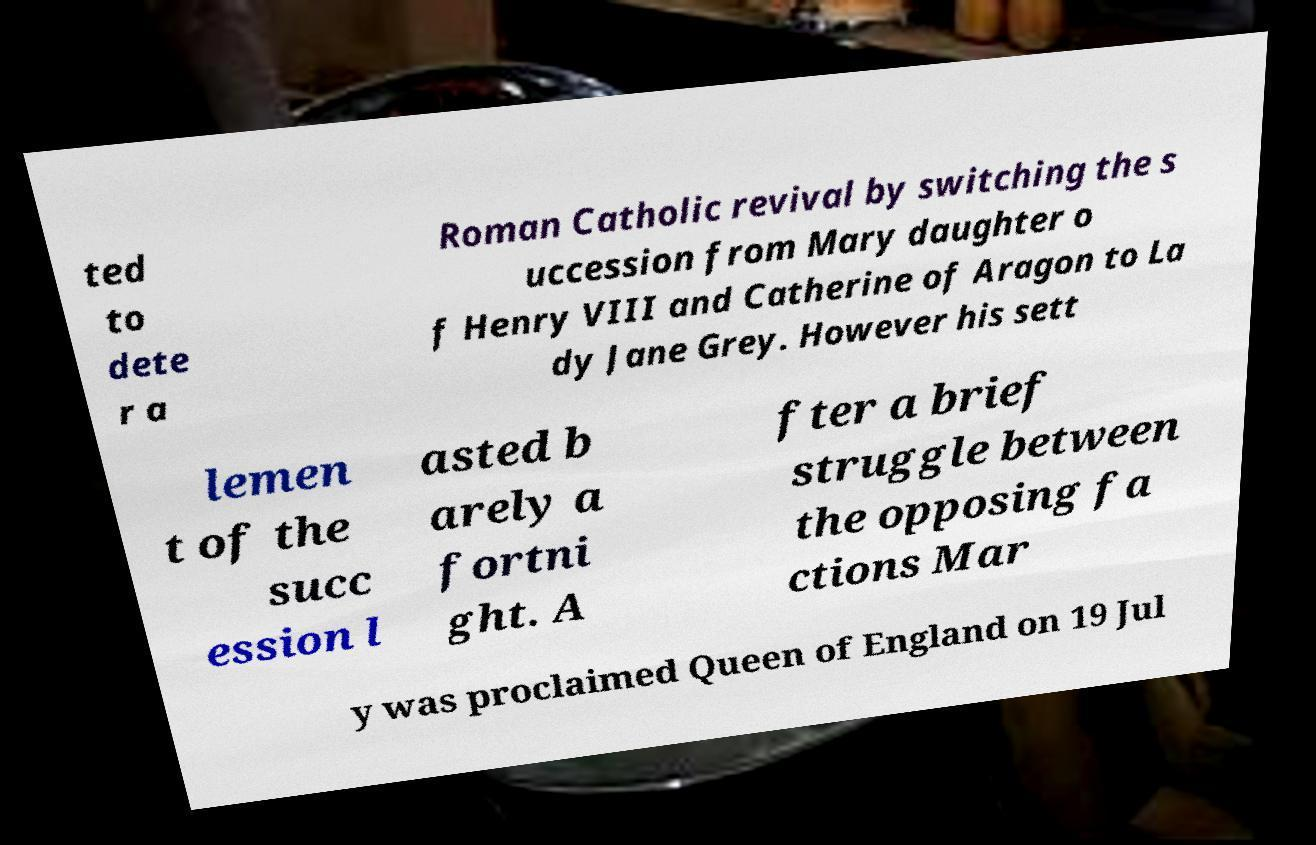There's text embedded in this image that I need extracted. Can you transcribe it verbatim? ted to dete r a Roman Catholic revival by switching the s uccession from Mary daughter o f Henry VIII and Catherine of Aragon to La dy Jane Grey. However his sett lemen t of the succ ession l asted b arely a fortni ght. A fter a brief struggle between the opposing fa ctions Mar y was proclaimed Queen of England on 19 Jul 